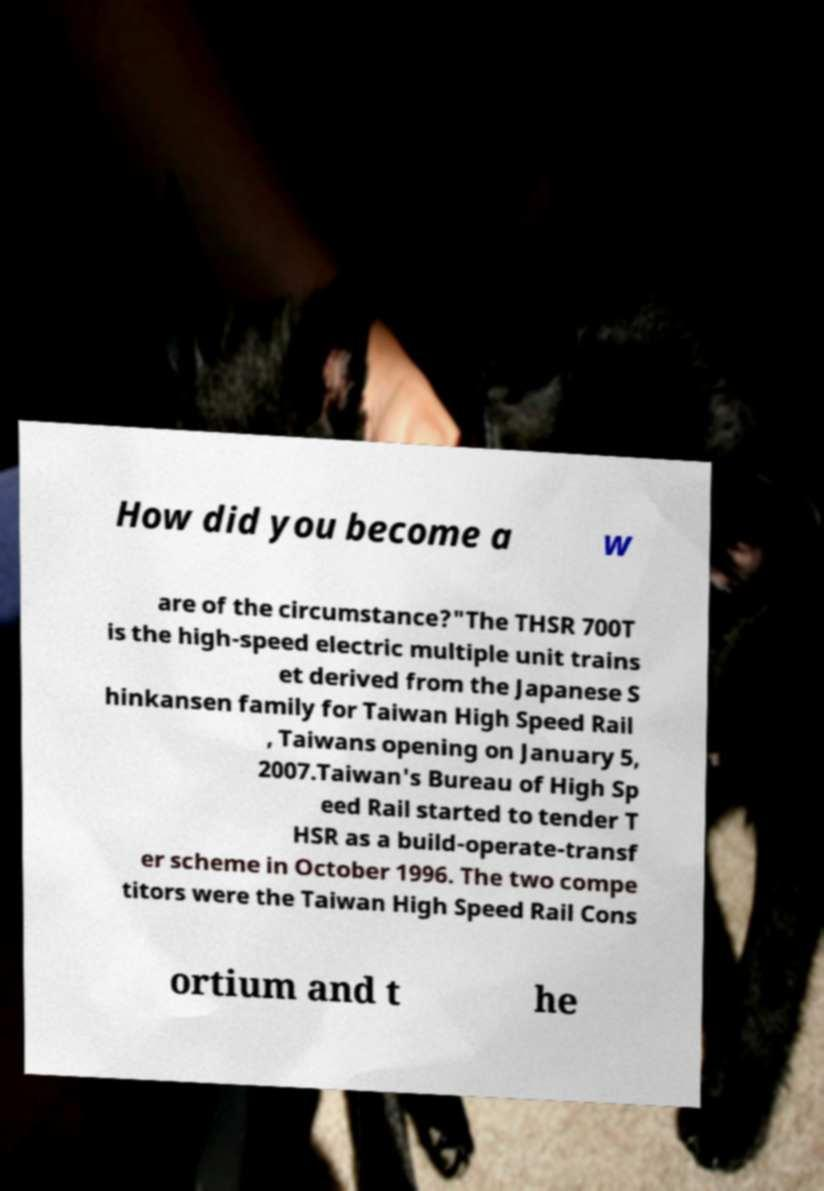Can you accurately transcribe the text from the provided image for me? How did you become a w are of the circumstance?"The THSR 700T is the high-speed electric multiple unit trains et derived from the Japanese S hinkansen family for Taiwan High Speed Rail , Taiwans opening on January 5, 2007.Taiwan's Bureau of High Sp eed Rail started to tender T HSR as a build-operate-transf er scheme in October 1996. The two compe titors were the Taiwan High Speed Rail Cons ortium and t he 